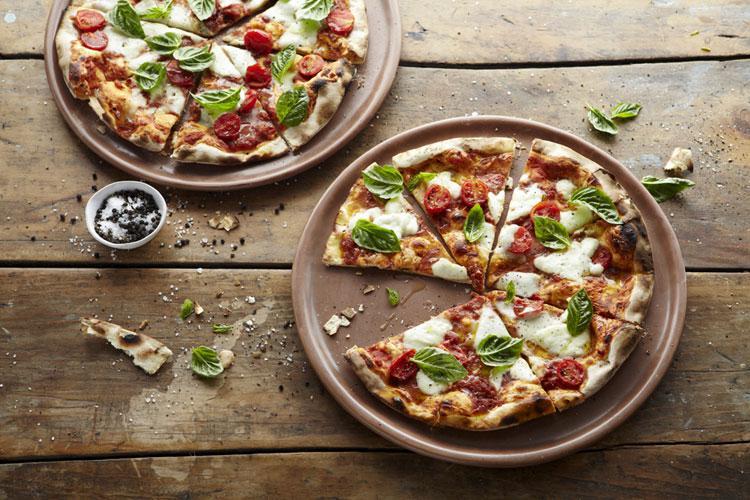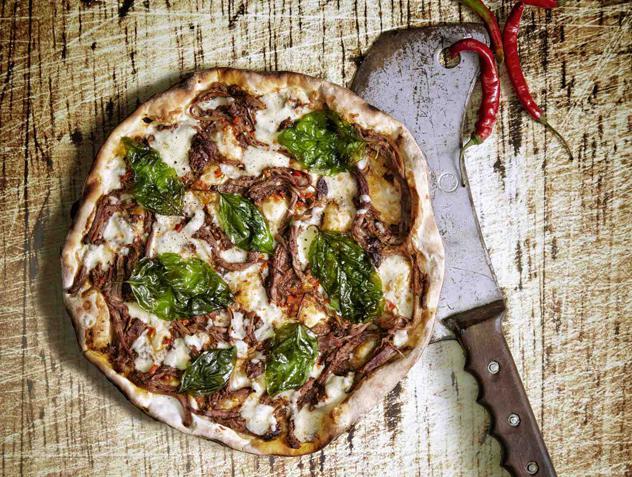The first image is the image on the left, the second image is the image on the right. Evaluate the accuracy of this statement regarding the images: "The left image includes at least two round platters of food and at least one small condiment cup next to a sliced pizza on a brown plank surface.". Is it true? Answer yes or no. Yes. The first image is the image on the left, the second image is the image on the right. Examine the images to the left and right. Is the description "Part of a pizza is missing." accurate? Answer yes or no. Yes. 